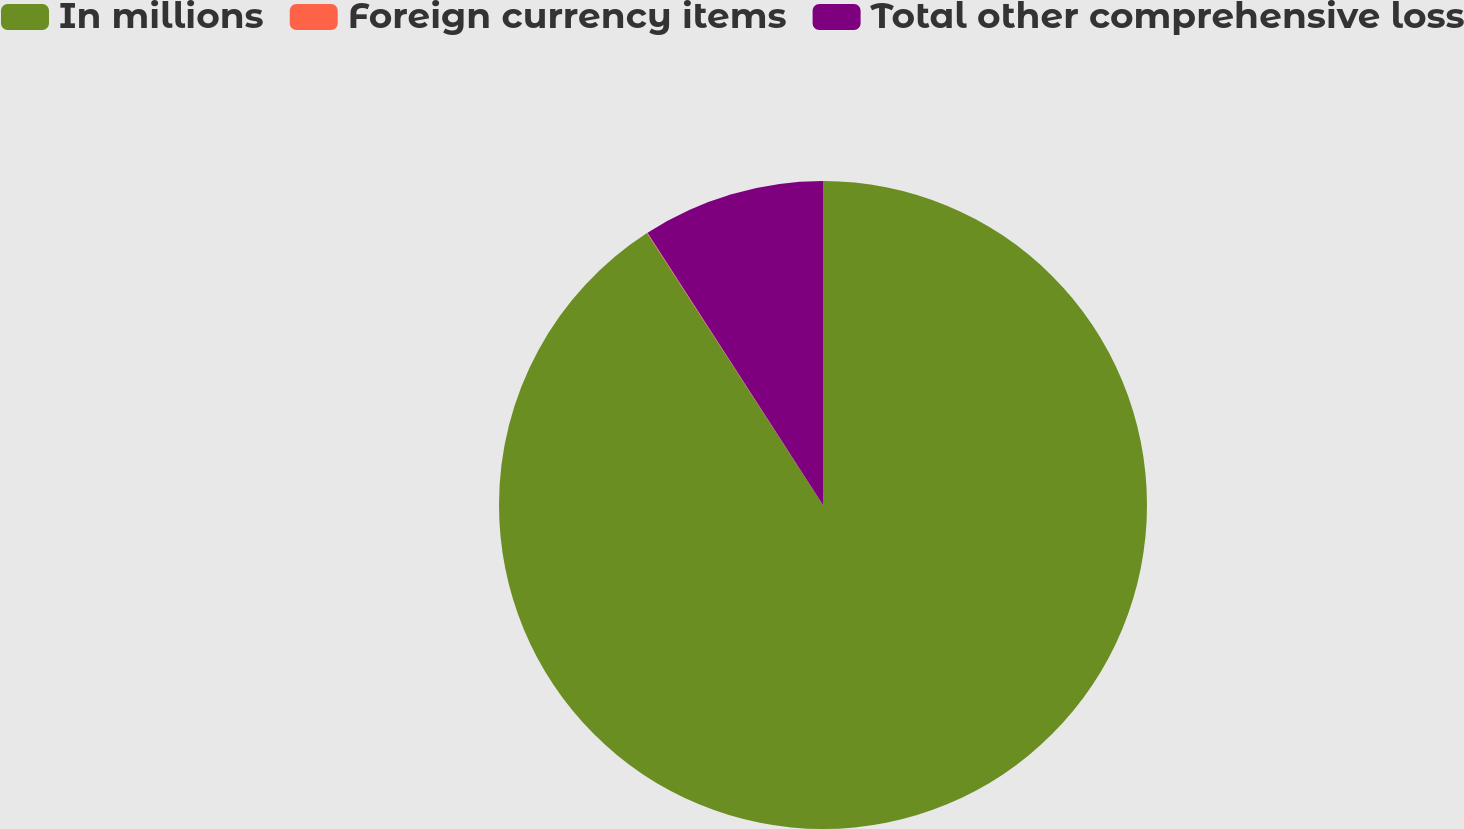Convert chart. <chart><loc_0><loc_0><loc_500><loc_500><pie_chart><fcel>In millions<fcel>Foreign currency items<fcel>Total other comprehensive loss<nl><fcel>90.85%<fcel>0.03%<fcel>9.11%<nl></chart> 